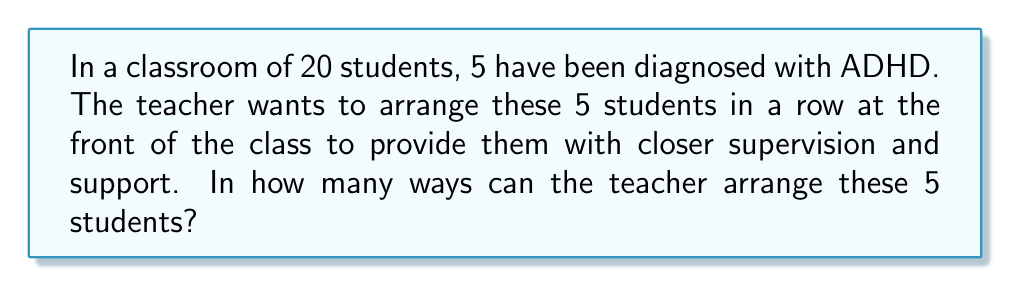Provide a solution to this math problem. To solve this problem, we need to understand the concept of permutations. A permutation is an arrangement of objects where order matters.

In this case:
1. We have 5 students with ADHD to arrange.
2. The order of arrangement matters (e.g., Student A sitting in the first seat is different from Student A sitting in the second seat).
3. All 5 students must be used in each arrangement.

This scenario fits the formula for permutations of n distinct objects:

$$P(n) = n!$$

Where:
- $n$ is the number of objects to be arranged
- $!$ denotes the factorial operation

For our problem:
- $n = 5$ (5 students with ADHD)

Therefore, the number of possible arrangements is:

$$P(5) = 5!$$

To calculate this:

$$\begin{align}
5! &= 5 \times 4 \times 3 \times 2 \times 1 \\
&= 120
\end{align}$$

This result aligns with the cognitive needs of students with ADHD. By considering different seating arrangements, the teacher can find the optimal setup that minimizes distractions and maximizes support for these students, which is crucial for creating an inclusive classroom environment.
Answer: $120$ possible arrangements 